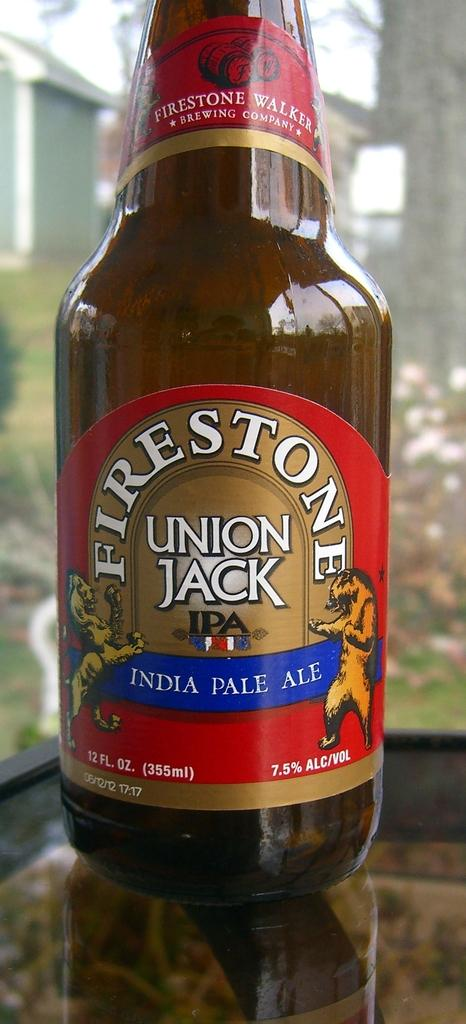What object can be seen in the image? There is a bottle in the image. What is unique about the bottle? The bottle has stickers on it. What can be seen in the distance in the image? There is a house and trees in the background of the image. What type of weather can be seen in the image? There is no indication of weather in the image; it only shows a bottle with stickers and a background with a house and trees. 